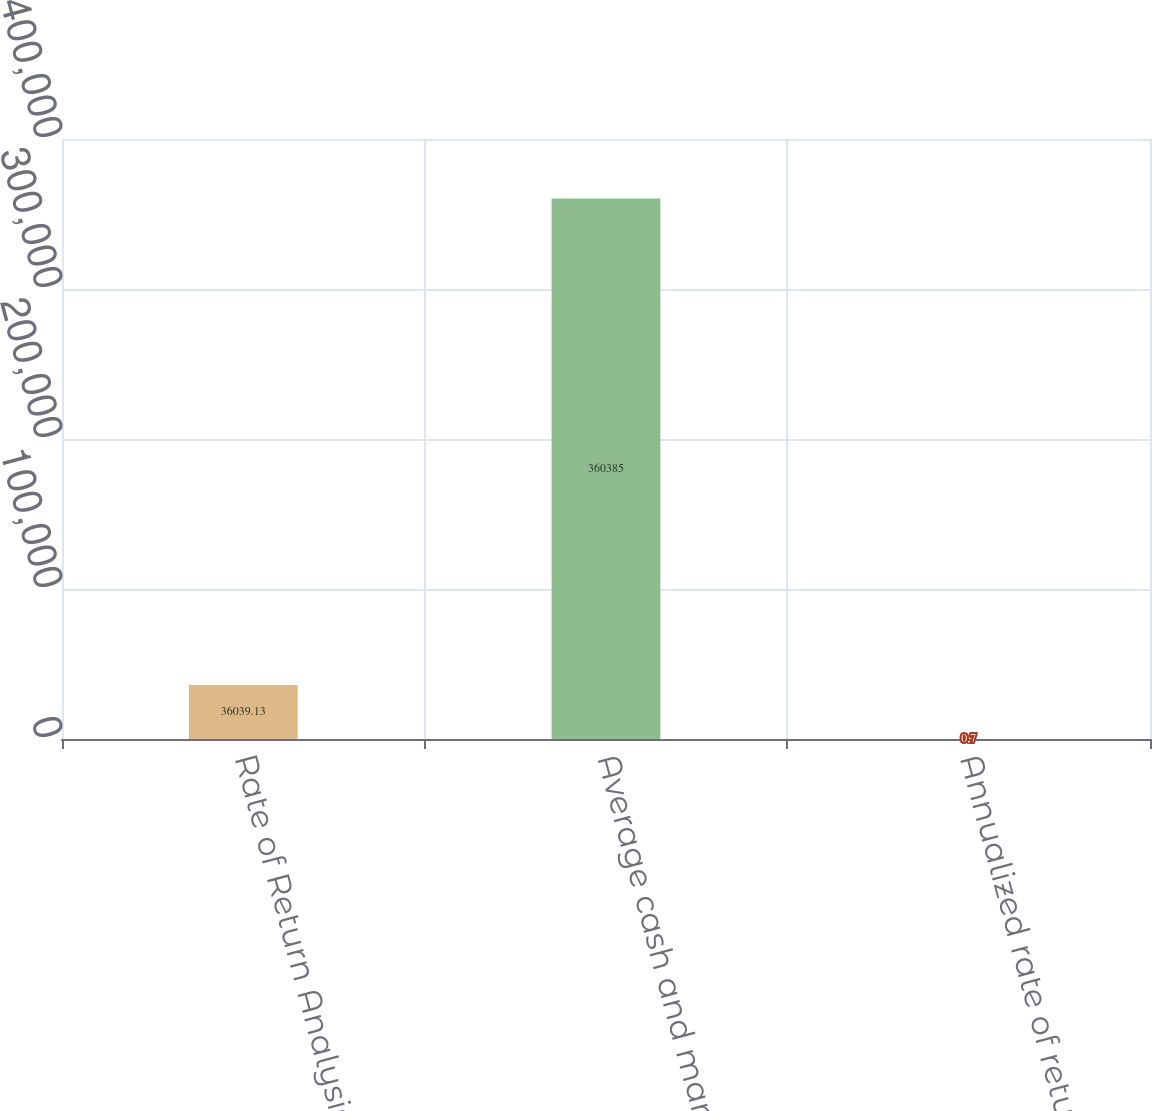<chart> <loc_0><loc_0><loc_500><loc_500><bar_chart><fcel>Rate of Return Analysis<fcel>Average cash and marketable<fcel>Annualized rate of return<nl><fcel>36039.1<fcel>360385<fcel>0.7<nl></chart> 